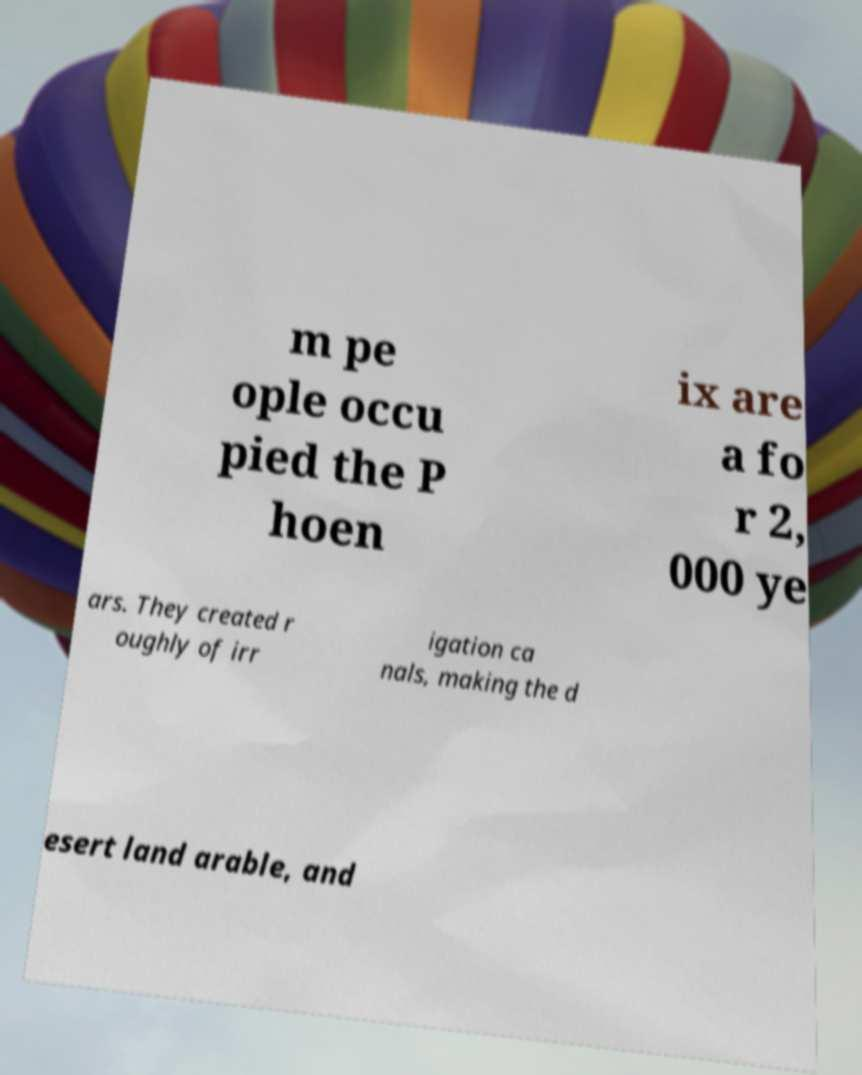There's text embedded in this image that I need extracted. Can you transcribe it verbatim? m pe ople occu pied the P hoen ix are a fo r 2, 000 ye ars. They created r oughly of irr igation ca nals, making the d esert land arable, and 